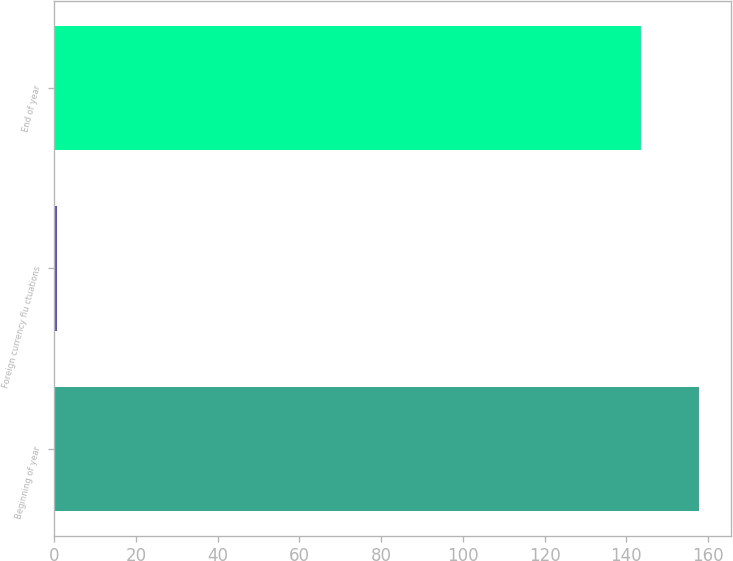<chart> <loc_0><loc_0><loc_500><loc_500><bar_chart><fcel>Beginning of year<fcel>Foreign currency flu ctuations<fcel>End of year<nl><fcel>157.85<fcel>0.6<fcel>143.5<nl></chart> 